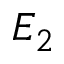Convert formula to latex. <formula><loc_0><loc_0><loc_500><loc_500>E _ { 2 }</formula> 